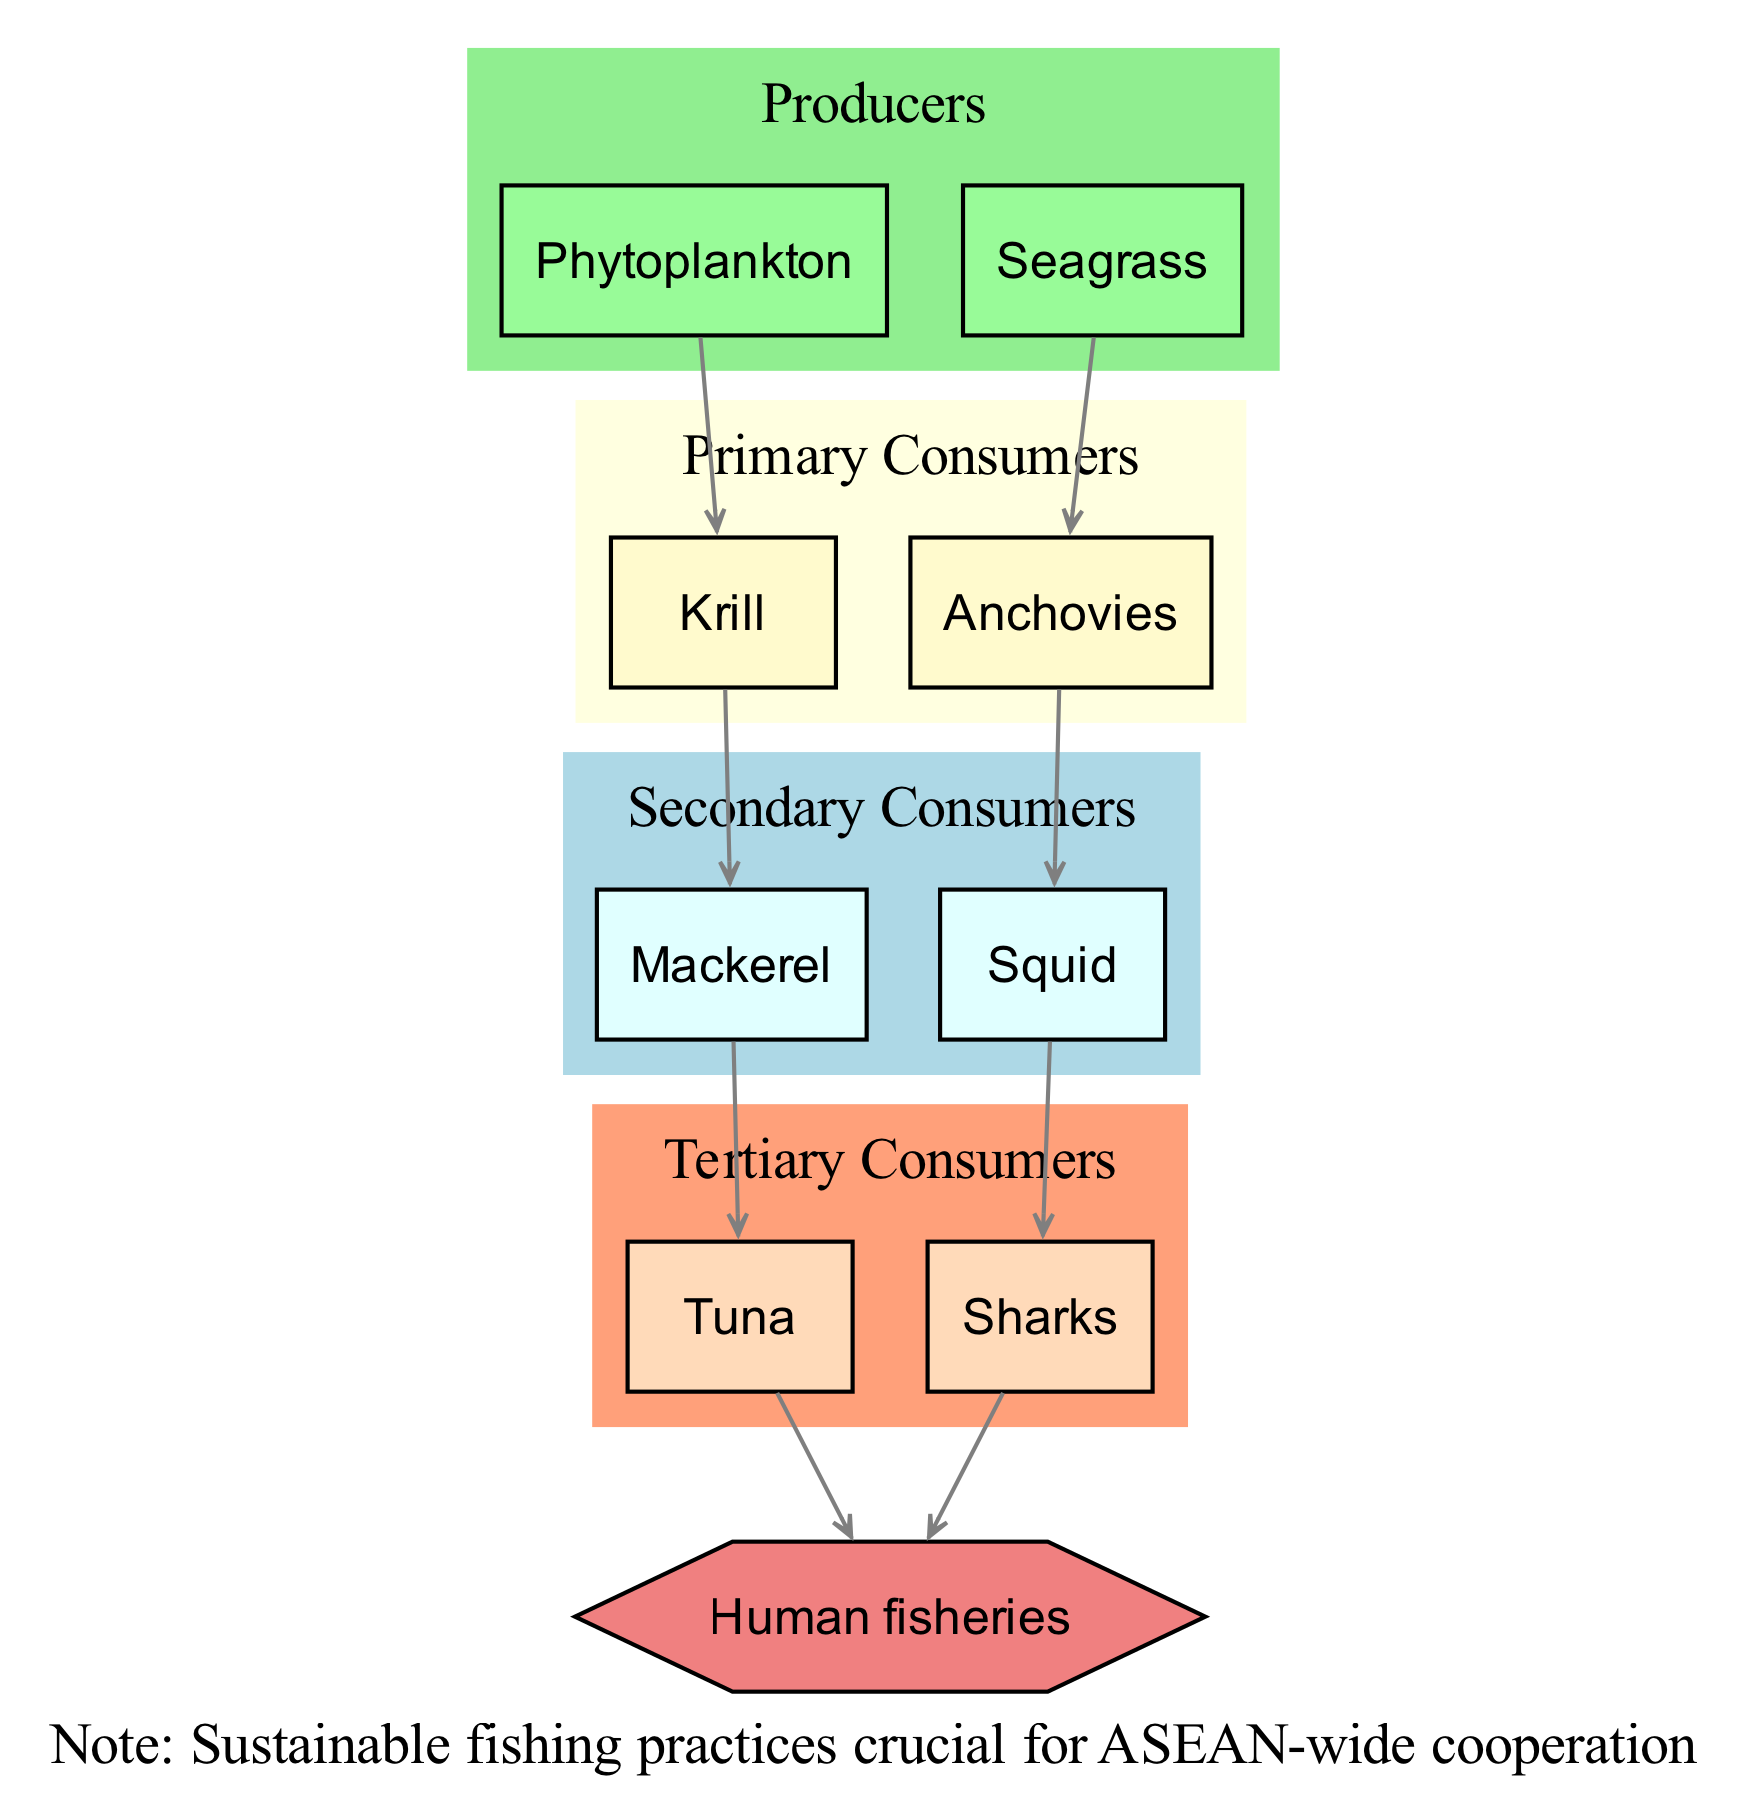What are the primary producers in the South China Sea ecosystem? The primary producers listed in the diagram are phytoplankton and seagrass. These are the foundational organisms that convert sunlight into energy through photosynthesis, forming the base of the marine food web.
Answer: Phytoplankton, Seagrass How many trophic levels are present in the diagram? The diagram includes five distinct trophic levels: producers, primary consumers, secondary consumers, tertiary consumers, and apex predator. Therefore, counting each category gives us five trophic levels.
Answer: 5 Which organism is classified as a tertiary consumer? From the diagram, mackerel and sharks are categorized as secondary consumers. However, when looking specifically for a tertiary consumer, tuna fits this classification as it feeds primarily on mackerel.
Answer: Tuna What is the apex predator in the South China Sea food web? The apex predator identified in the diagram is human fisheries. This indicates that humans, through fishing practices, sit at the top of the marine food web.
Answer: Human fisheries How many connections are represented in the diagram? The diagram presents several connections between the various organisms, specifically 8 connections that describe the flow of energy and matter from one trophic level to another.
Answer: 8 What do tuna and sharks have in common according to the diagram? Both tuna and sharks share a connection in that they are both at the top of the food web as tertiary consumers feeding at the same level. Additionally, both are preyed upon by human fisheries, making them both apex consumers.
Answer: Preyed upon by human fisheries What type of fishing practices are considered crucial for ASEAN-wide cooperation? The diagram includes a diplomatic note stating that sustainable fishing practices are essential for cooperation among ASEAN nations, indicating that fishing must be managed to preserve the ecosystem.
Answer: Sustainable fishing practices What organisms do krill consume? According to the connections in the diagram, krill feed on phytoplankton, obtaining energy from these producers at the base of the marine food web.
Answer: Phytoplankton Which are the primary consumers linked to seagrass? The diagram connects seagrass to anchovies categorized as primary consumers. This indicates that anchovies gain their energy from consuming seagrass.
Answer: Anchovies 